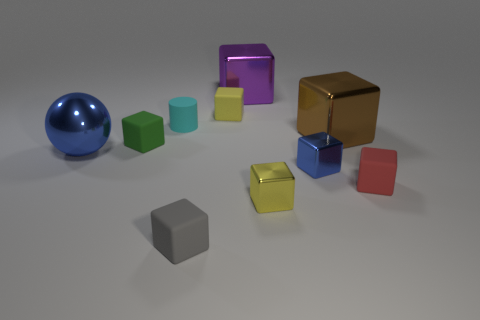Subtract all large purple metallic cubes. How many cubes are left? 7 Subtract all brown blocks. How many blocks are left? 7 Subtract 5 blocks. How many blocks are left? 3 Subtract all green blocks. Subtract all red balls. How many blocks are left? 7 Subtract all balls. How many objects are left? 9 Add 6 green objects. How many green objects exist? 7 Subtract 0 cyan cubes. How many objects are left? 10 Subtract all big red balls. Subtract all big blue spheres. How many objects are left? 9 Add 7 large brown objects. How many large brown objects are left? 8 